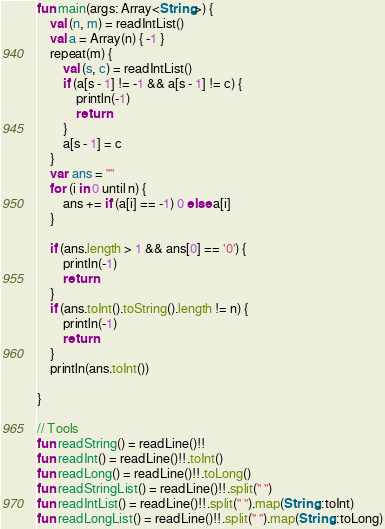Convert code to text. <code><loc_0><loc_0><loc_500><loc_500><_Kotlin_>fun main(args: Array<String>) {
    val (n, m) = readIntList()
    val a = Array(n) { -1 }
    repeat(m) {
        val (s, c) = readIntList()
        if (a[s - 1] != -1 && a[s - 1] != c) {
            println(-1)
            return
        }
        a[s - 1] = c
    }
    var ans = ""
    for (i in 0 until n) {
        ans += if (a[i] == -1) 0 else a[i]
    }

    if (ans.length > 1 && ans[0] == '0') {
        println(-1)
        return
    }
    if (ans.toInt().toString().length != n) {
        println(-1)
        return
    }
    println(ans.toInt())

}

// Tools
fun readString() = readLine()!!
fun readInt() = readLine()!!.toInt()
fun readLong() = readLine()!!.toLong()
fun readStringList() = readLine()!!.split(" ")
fun readIntList() = readLine()!!.split(" ").map(String::toInt)
fun readLongList() = readLine()!!.split(" ").map(String::toLong)</code> 